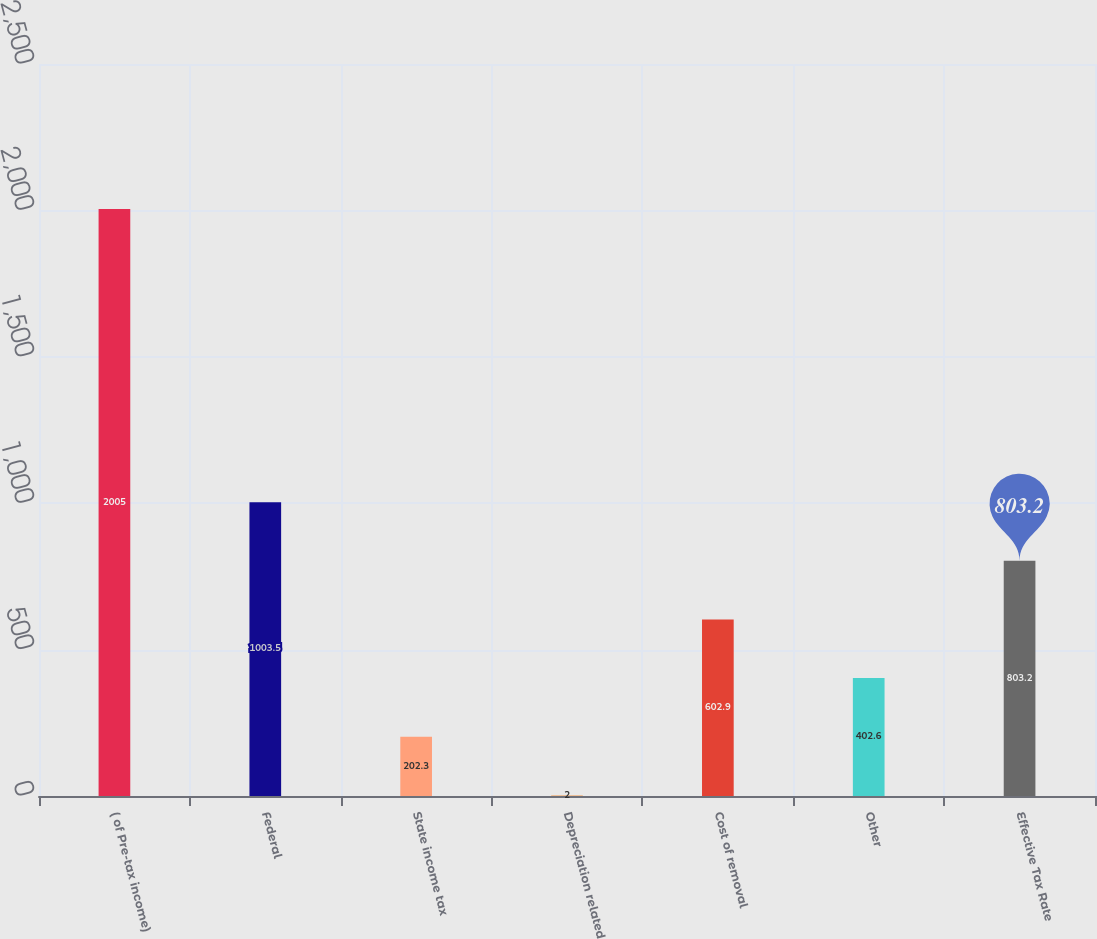Convert chart to OTSL. <chart><loc_0><loc_0><loc_500><loc_500><bar_chart><fcel>( of Pre-tax income)<fcel>Federal<fcel>State income tax<fcel>Depreciation related<fcel>Cost of removal<fcel>Other<fcel>Effective Tax Rate<nl><fcel>2005<fcel>1003.5<fcel>202.3<fcel>2<fcel>602.9<fcel>402.6<fcel>803.2<nl></chart> 